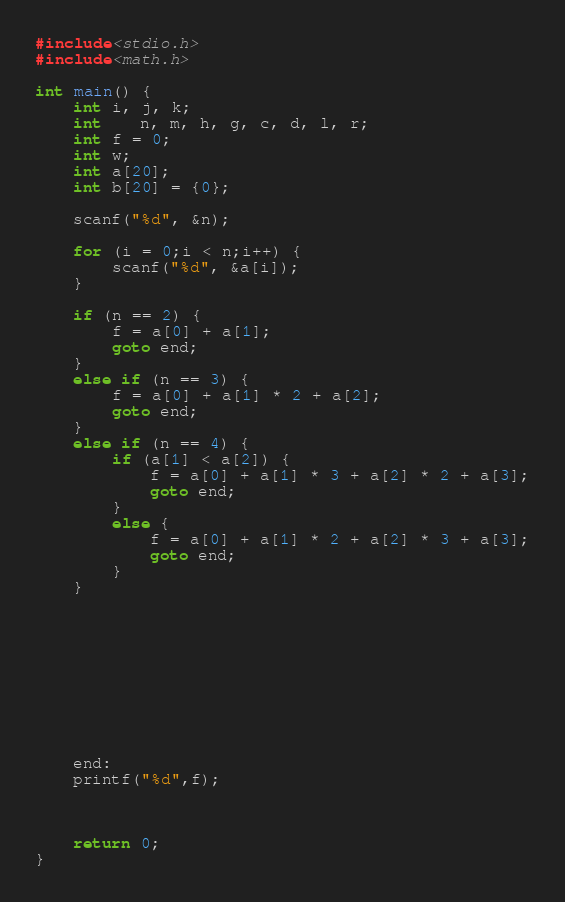Convert code to text. <code><loc_0><loc_0><loc_500><loc_500><_C_>#include<stdio.h>
#include<math.h>

int main() {
	int i, j, k;
	int	n, m, h, g, c, d, l, r;
	int f = 0;
	int w;
	int a[20];
	int b[20] = {0};

	scanf("%d", &n);

	for (i = 0;i < n;i++) {
		scanf("%d", &a[i]);
	}

	if (n == 2) {
		f = a[0] + a[1];
		goto end;
	}
	else if (n == 3) {
		f = a[0] + a[1] * 2 + a[2];
		goto end;
	}
	else if (n == 4) {
		if (a[1] < a[2]) {
			f = a[0] + a[1] * 3 + a[2] * 2 + a[3];
			goto end;
		}
		else {
			f = a[0] + a[1] * 2 + a[2] * 3 + a[3];
			goto end;
		}
	}










	end:
	printf("%d",f);



	return 0;
}</code> 